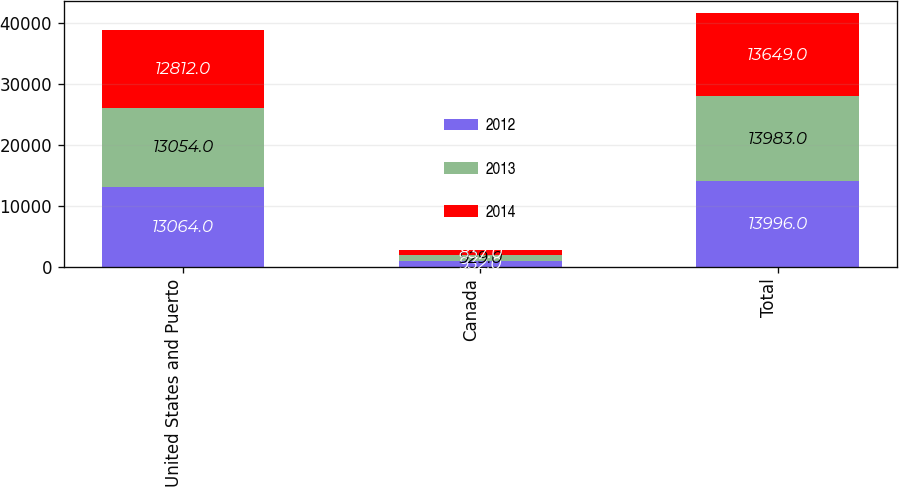Convert chart. <chart><loc_0><loc_0><loc_500><loc_500><stacked_bar_chart><ecel><fcel>United States and Puerto<fcel>Canada<fcel>Total<nl><fcel>2012<fcel>13064<fcel>932<fcel>13996<nl><fcel>2013<fcel>13054<fcel>929<fcel>13983<nl><fcel>2014<fcel>12812<fcel>837<fcel>13649<nl></chart> 